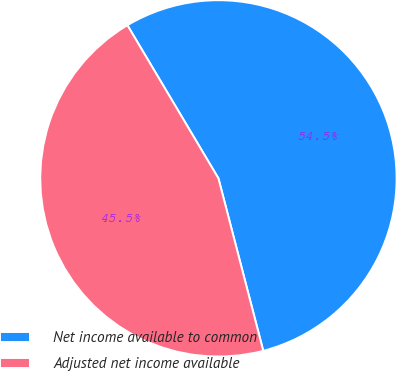<chart> <loc_0><loc_0><loc_500><loc_500><pie_chart><fcel>Net income available to common<fcel>Adjusted net income available<nl><fcel>54.49%<fcel>45.51%<nl></chart> 